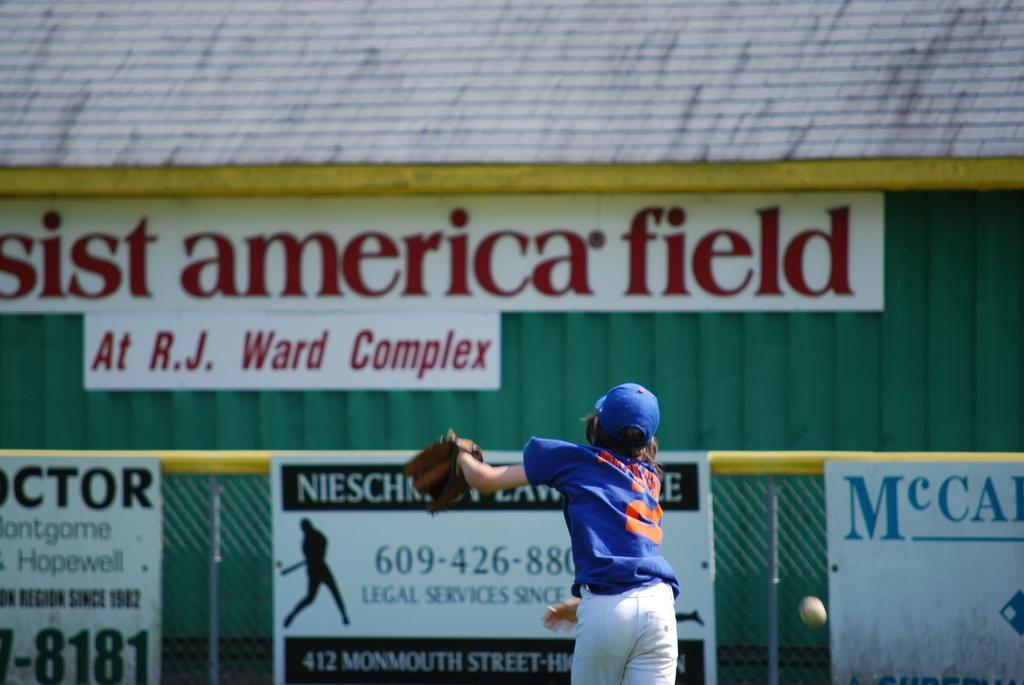Provide a one-sentence caption for the provided image. A baseball game is being played on a field at R.J. Ward Complex. 